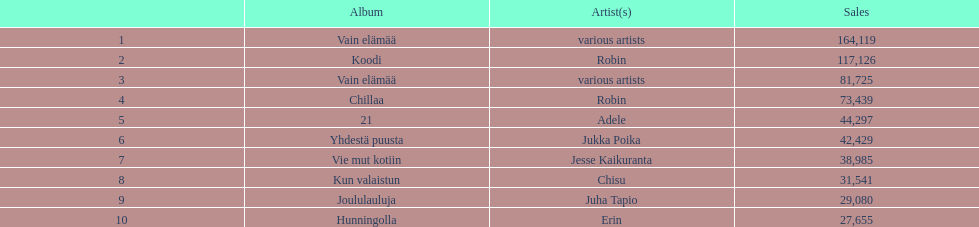Which album had the least amount of sales? Hunningolla. 